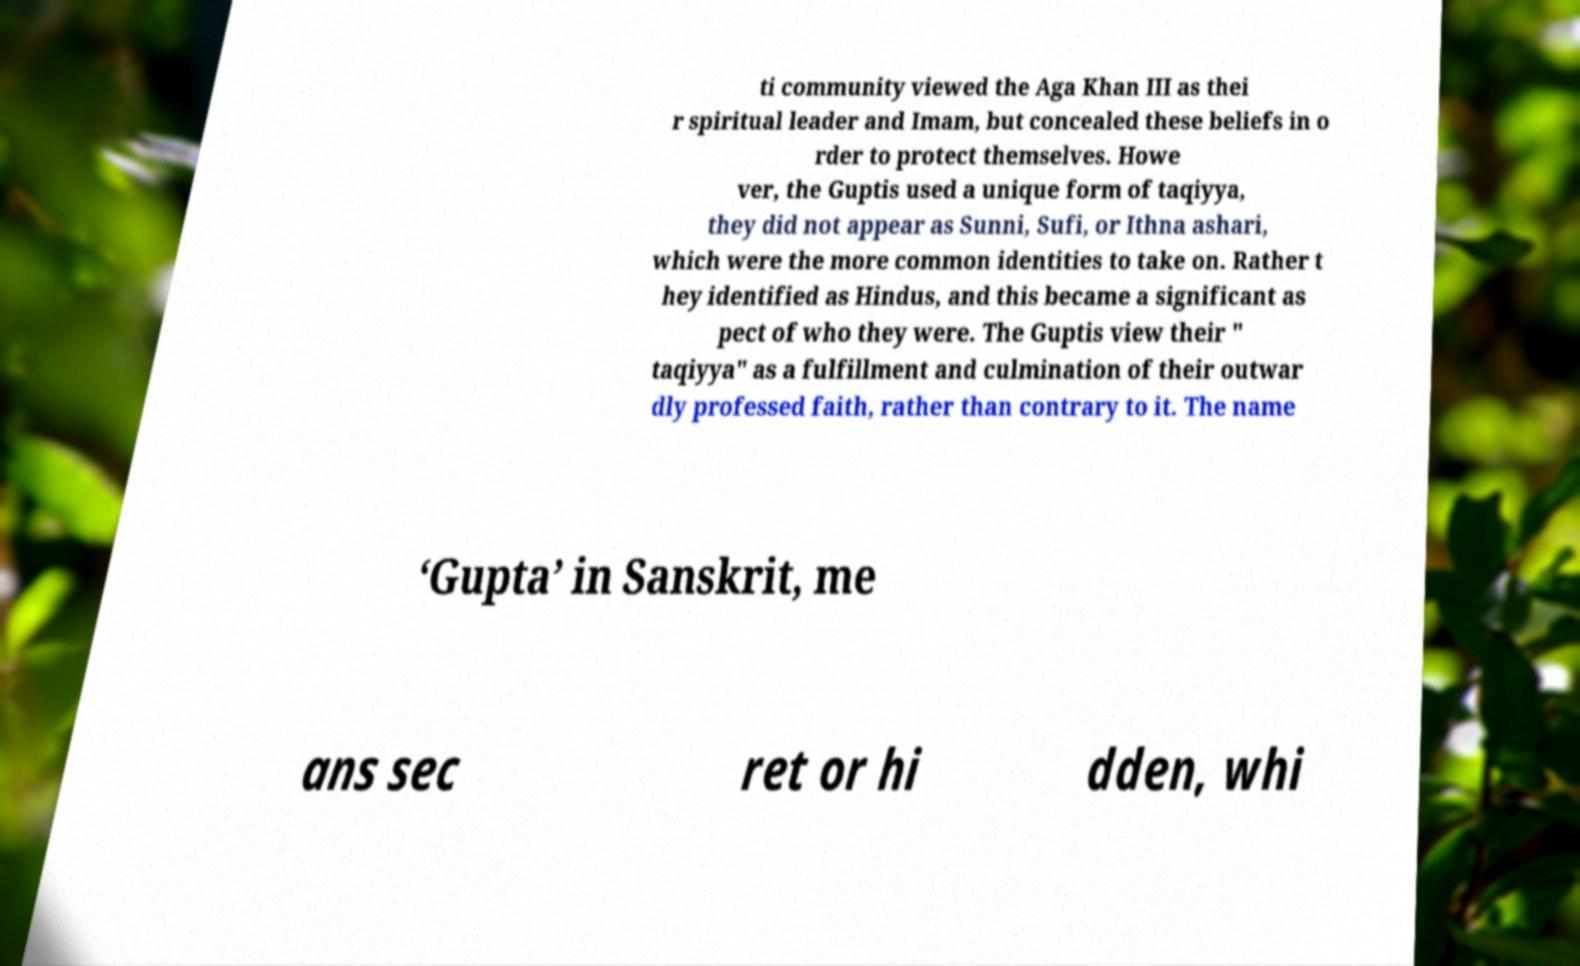What messages or text are displayed in this image? I need them in a readable, typed format. ti community viewed the Aga Khan III as thei r spiritual leader and Imam, but concealed these beliefs in o rder to protect themselves. Howe ver, the Guptis used a unique form of taqiyya, they did not appear as Sunni, Sufi, or Ithna ashari, which were the more common identities to take on. Rather t hey identified as Hindus, and this became a significant as pect of who they were. The Guptis view their " taqiyya" as a fulfillment and culmination of their outwar dly professed faith, rather than contrary to it. The name ‘Gupta’ in Sanskrit, me ans sec ret or hi dden, whi 